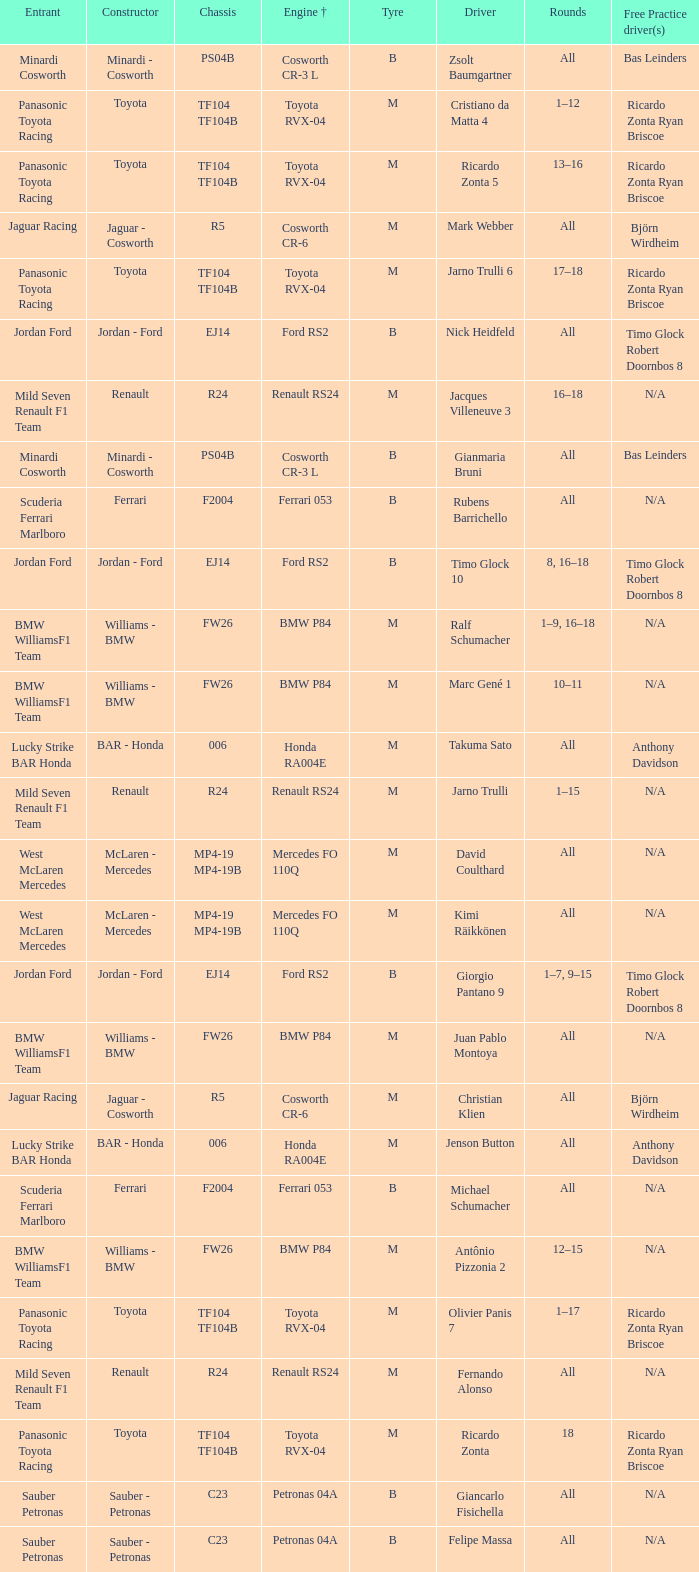What kind of chassis does Ricardo Zonta have? TF104 TF104B. 